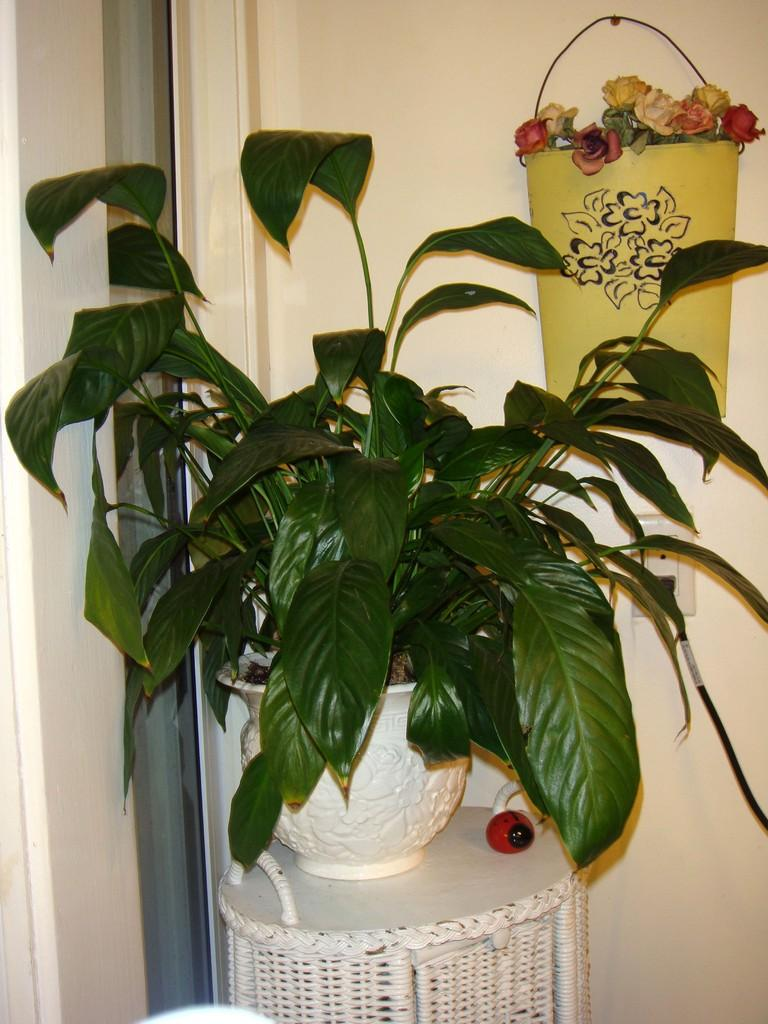What is the main subject in the center of the image? There is a plant in a pot in the center of the image. How is the plant positioned in the image? The plant is on a stool. What else can be seen in the image besides the plant? There are flowers in a basket hanging on the wall. What type of carriage is used to transport the notebook in the image? There is no carriage or notebook present in the image. 